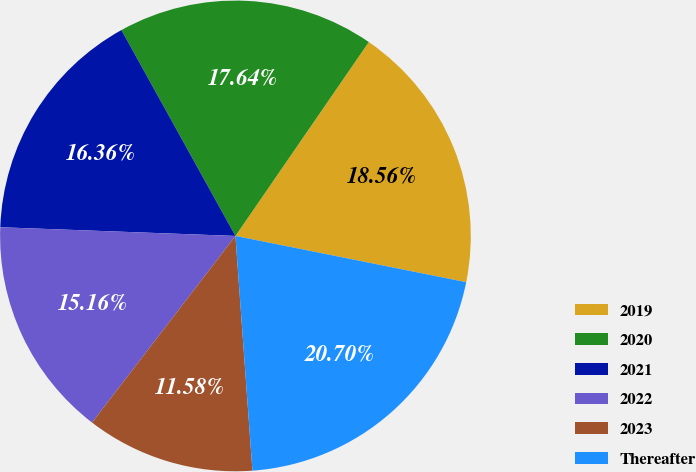Convert chart to OTSL. <chart><loc_0><loc_0><loc_500><loc_500><pie_chart><fcel>2019<fcel>2020<fcel>2021<fcel>2022<fcel>2023<fcel>Thereafter<nl><fcel>18.56%<fcel>17.64%<fcel>16.36%<fcel>15.16%<fcel>11.58%<fcel>20.7%<nl></chart> 